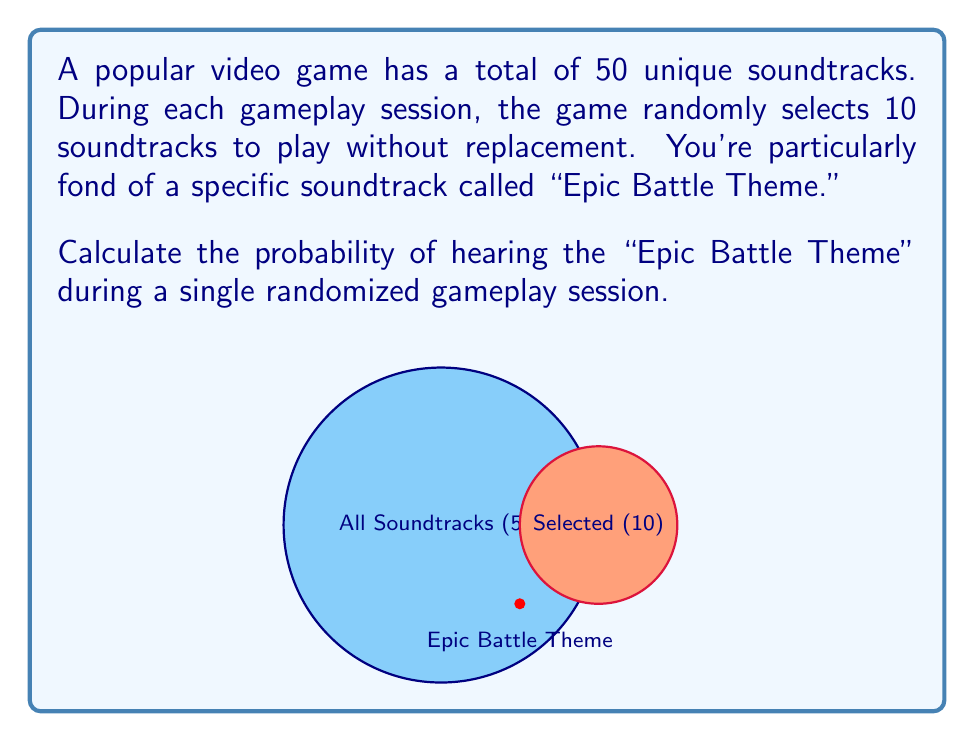Give your solution to this math problem. Let's approach this step-by-step using the principles of probability and combinatorics:

1) We can view this as a problem of selecting 10 soundtracks out of 50, where we want to know the probability that our favorite soundtrack is among those 10.

2) There are two possible outcomes for the "Epic Battle Theme":
   a) It is selected
   b) It is not selected

3) The probability of it being selected is equivalent to 1 minus the probability of it not being selected.

4) To calculate the probability of it not being selected:
   - We need to choose 10 soundtracks from the 49 that are not the "Epic Battle Theme"
   - This can be done in $\binom{49}{10}$ ways

5) The total number of ways to choose 10 soundtracks from 50 is $\binom{50}{10}$

6) Therefore, the probability of not selecting the "Epic Battle Theme" is:

   $$P(\text{not selected}) = \frac{\binom{49}{10}}{\binom{50}{10}}$$

7) The probability of selecting it is:

   $$P(\text{selected}) = 1 - P(\text{not selected}) = 1 - \frac{\binom{49}{10}}{\binom{50}{10}}$$

8) Calculating this:
   $$1 - \frac{49!/(10!39!)}{50!/(10!40!)} = 1 - \frac{49!40!}{50!39!} = 1 - \frac{40}{50} = \frac{1}{5} = 0.2$$

Thus, the probability of hearing the "Epic Battle Theme" during a single randomized gameplay session is 0.2 or 20%.
Answer: $\frac{1}{5}$ or $0.2$ or $20\%$ 